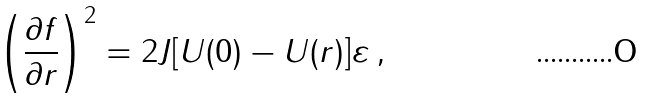Convert formula to latex. <formula><loc_0><loc_0><loc_500><loc_500>\left ( \frac { \partial f } { \partial r } \right ) ^ { 2 } = { 2 J [ U ( 0 ) - U ( r ) ] \varepsilon } \, ,</formula> 